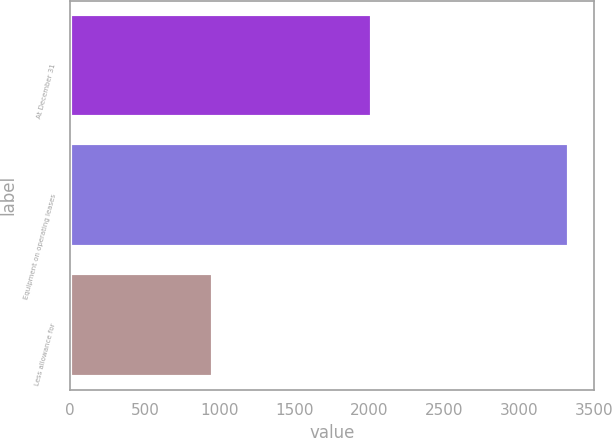<chart> <loc_0><loc_0><loc_500><loc_500><bar_chart><fcel>At December 31<fcel>Equipment on operating leases<fcel>Less allowance for<nl><fcel>2015<fcel>3335.5<fcel>954.7<nl></chart> 